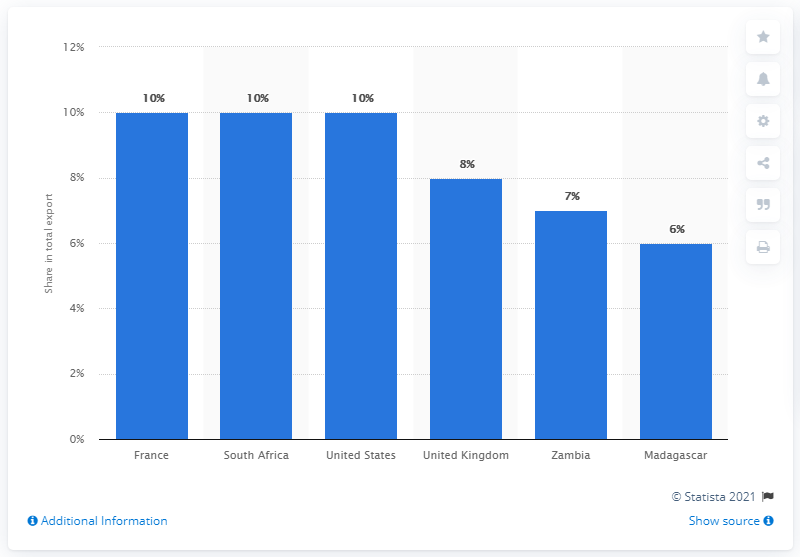Draw attention to some important aspects in this diagram. In 2019, Mauritius' main export partner was France. 